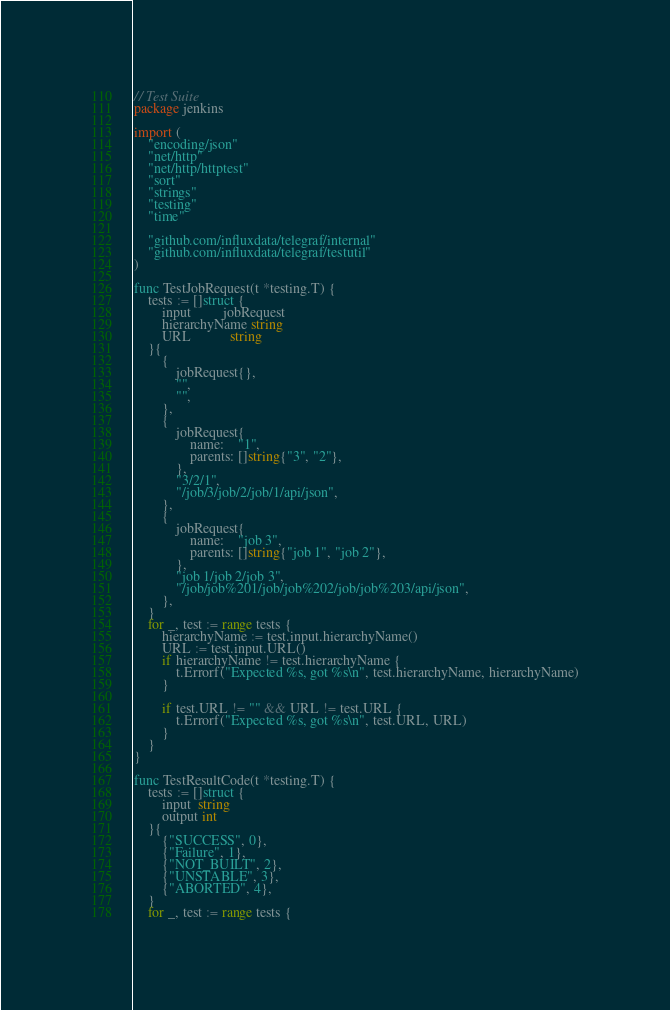<code> <loc_0><loc_0><loc_500><loc_500><_Go_>// Test Suite
package jenkins

import (
	"encoding/json"
	"net/http"
	"net/http/httptest"
	"sort"
	"strings"
	"testing"
	"time"

	"github.com/influxdata/telegraf/internal"
	"github.com/influxdata/telegraf/testutil"
)

func TestJobRequest(t *testing.T) {
	tests := []struct {
		input         jobRequest
		hierarchyName string
		URL           string
	}{
		{
			jobRequest{},
			"",
			"",
		},
		{
			jobRequest{
				name:    "1",
				parents: []string{"3", "2"},
			},
			"3/2/1",
			"/job/3/job/2/job/1/api/json",
		},
		{
			jobRequest{
				name:    "job 3",
				parents: []string{"job 1", "job 2"},
			},
			"job 1/job 2/job 3",
			"/job/job%201/job/job%202/job/job%203/api/json",
		},
	}
	for _, test := range tests {
		hierarchyName := test.input.hierarchyName()
		URL := test.input.URL()
		if hierarchyName != test.hierarchyName {
			t.Errorf("Expected %s, got %s\n", test.hierarchyName, hierarchyName)
		}

		if test.URL != "" && URL != test.URL {
			t.Errorf("Expected %s, got %s\n", test.URL, URL)
		}
	}
}

func TestResultCode(t *testing.T) {
	tests := []struct {
		input  string
		output int
	}{
		{"SUCCESS", 0},
		{"Failure", 1},
		{"NOT_BUILT", 2},
		{"UNSTABLE", 3},
		{"ABORTED", 4},
	}
	for _, test := range tests {</code> 